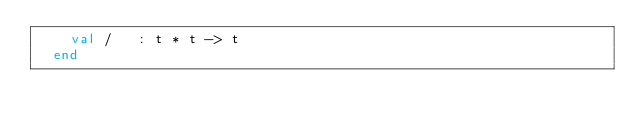Convert code to text. <code><loc_0><loc_0><loc_500><loc_500><_SML_>    val /   : t * t -> t
  end
</code> 